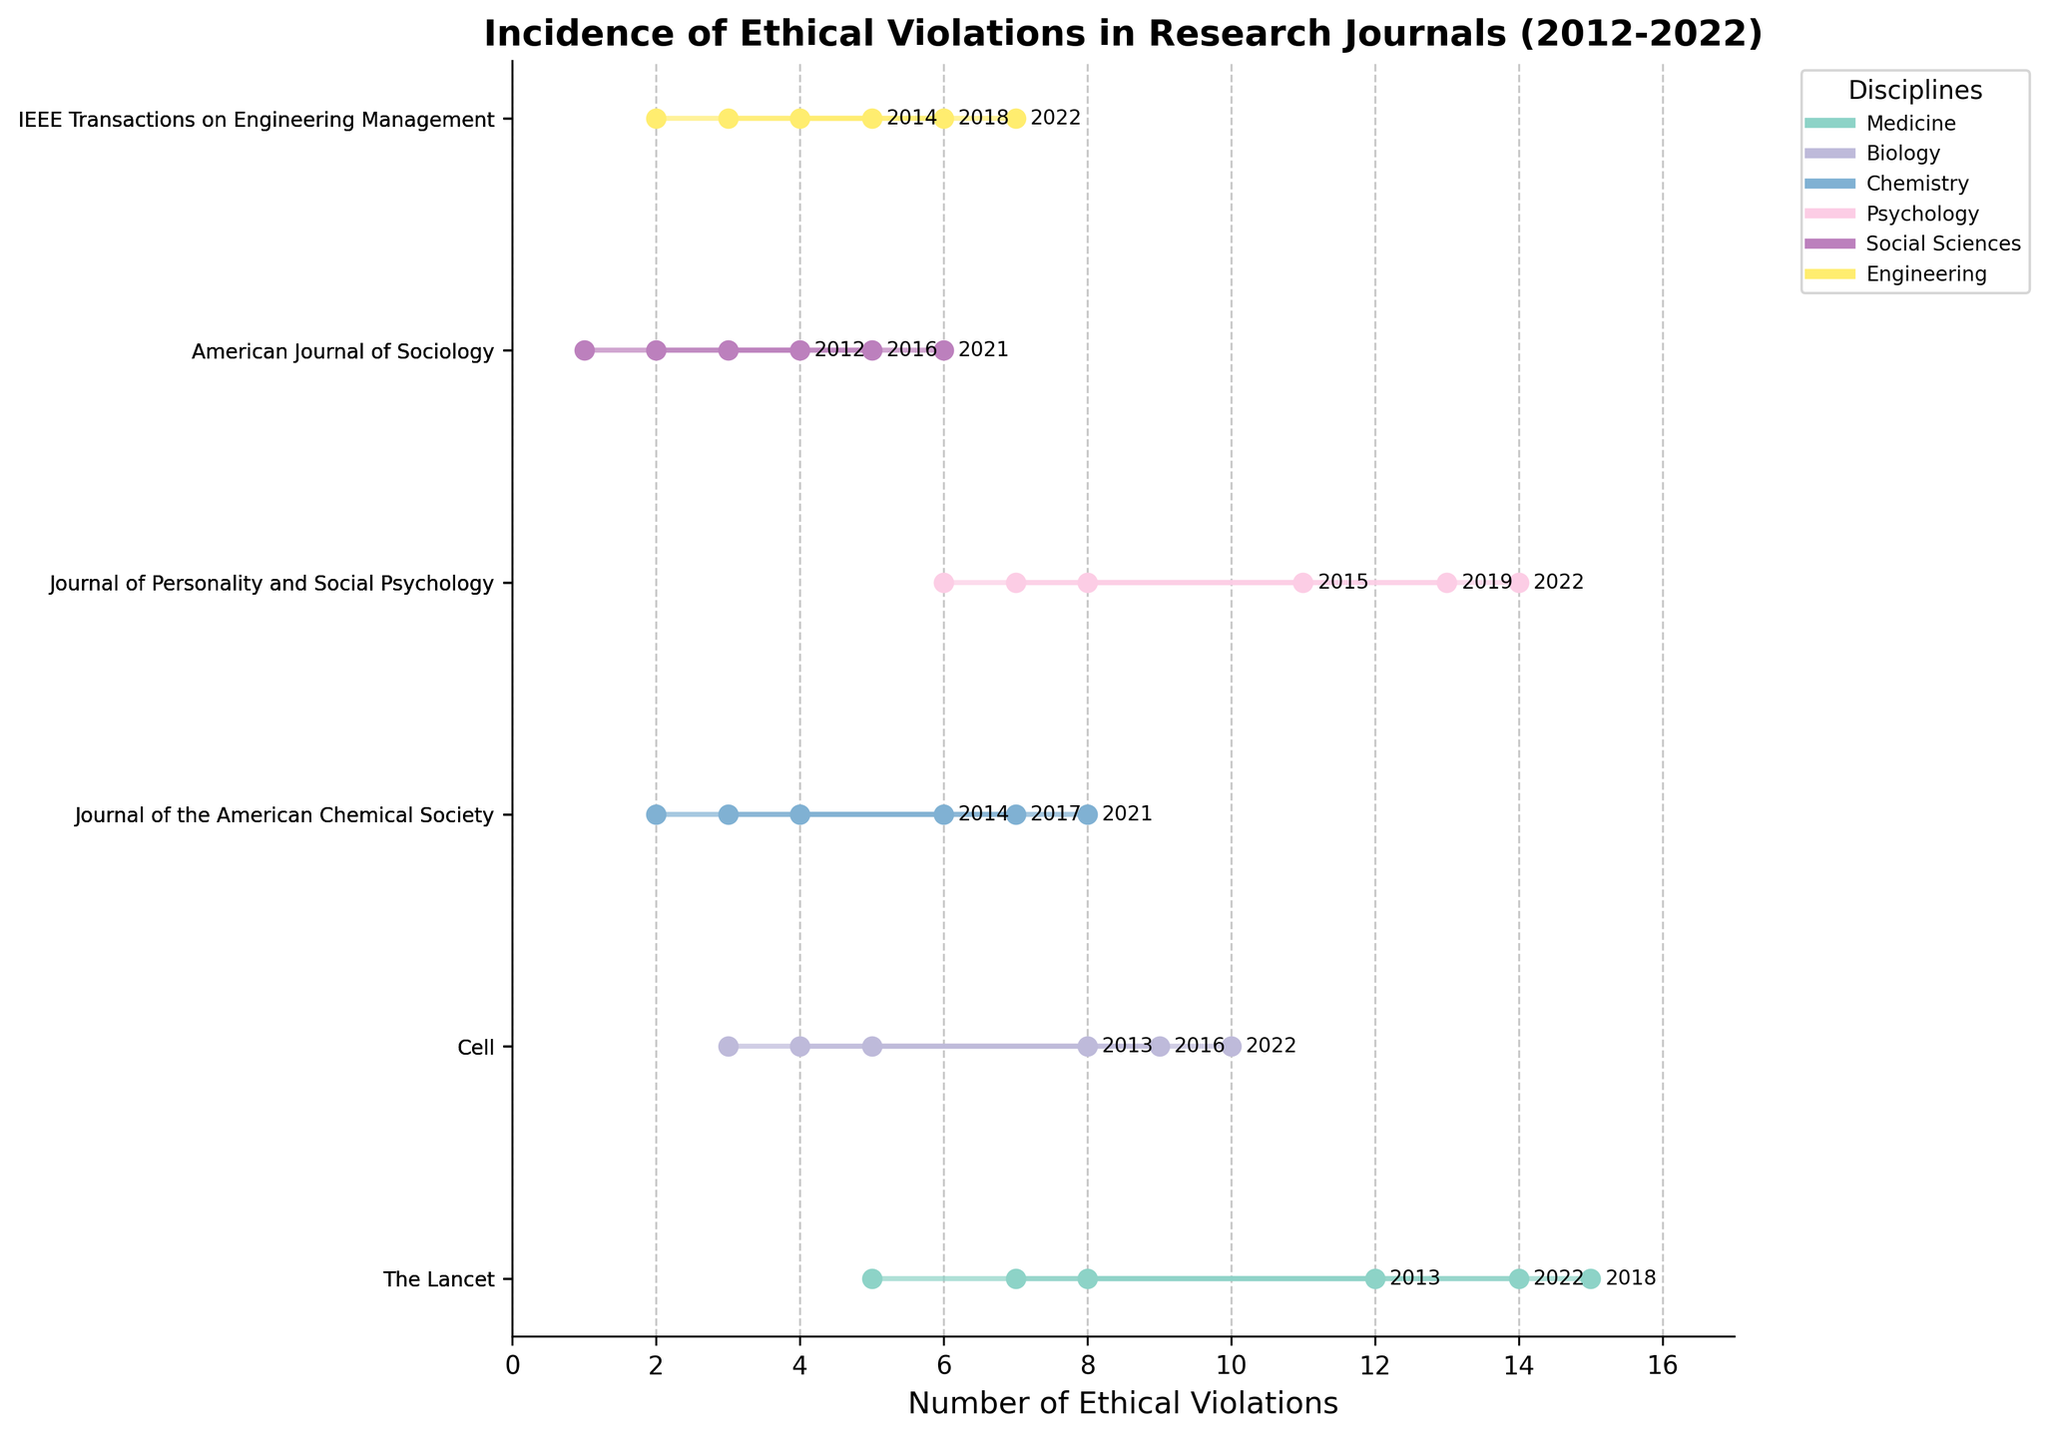What is the title of the plot? The title is usually displayed prominently at the top of the plot. In this case, it reads "Incidence of Ethical Violations in Research Journals (2012-2022)".
Answer: Incidence of Ethical Violations in Research Journals (2012-2022) Which journal in the Medicine discipline had the highest maximum incidents reported, and in which year? Look at the plot for the Medicine discipline. Here, "The Lancet" is represented, and its highest maximum incidents, marked by the rightmost dot, occur in 2018.
Answer: The Lancet, 2018 How many disciplines are represented in the plot? Each discipline is represented by a different color. By counting the unique colors or legend entries, you determine there are six disciplines.
Answer: Six What was the range of incidents for the Journal of Personality and Social Psychology in 2019? Locate the journal in the plot, then find the incidents on the x-axis corresponding to 2019. Connect the left (minimum) and right (maximum) dots of the line segment. It ranges from 7 to 13 incidents.
Answer: 7 to 13 Which discipline showed the greatest increase in minimum incidents reported over time? Compare the smallest recorded minimum incidents for each discipline at the earliest and latest years. For instance, see changes like from 3 to 10 in a discipline. Medicine increased from 5 in 2013 to 8 in 2018.
Answer: Medicine Which journal had the least number of maximum incidents reported across all disciplines? Look for the journal with the smallest maximum value point on the x-axis; the 4 value (2012). "American Journal of Sociology" max was 4 incidents.
Answer: American Journal of Sociology What trend is observed in ethical violations reported in the journal IEEE Transactions on Engineering Management from 2014 to 2022? Observe the plotted points and ranges for this journal from 2014 to 2022. The incidents range increases over time from 2-5 in 2014 to 4-7 in 2022.
Answer: Increasing trend Which journal and year had the narrowest range of incidents reported? Identify journal and year with the shortest line segment. "American Journal of Sociology" (2012), shows a narrow range of 1 to 4 incidents.
Answer: American Journal of Sociology, 2012 When comparing 2013 and 2022, which year had higher minimum incidents reported across all journals in the Biology discipline? Look at the minimum incidents for "Cell" in both 2013 and 2022. Compare these to see higher minimum reported in 2022 (5 versus 3).
Answer: 2022 Which disciplines had an increasing range of ethical violations over the presented years? For each discipline, compare early and late ranges (e.g., [2, 6] to [4,8] for Chemistry's Journal of the American Chemical Society) to see if the span (max-min) grows.
Answer: Chemistry, Engineering 